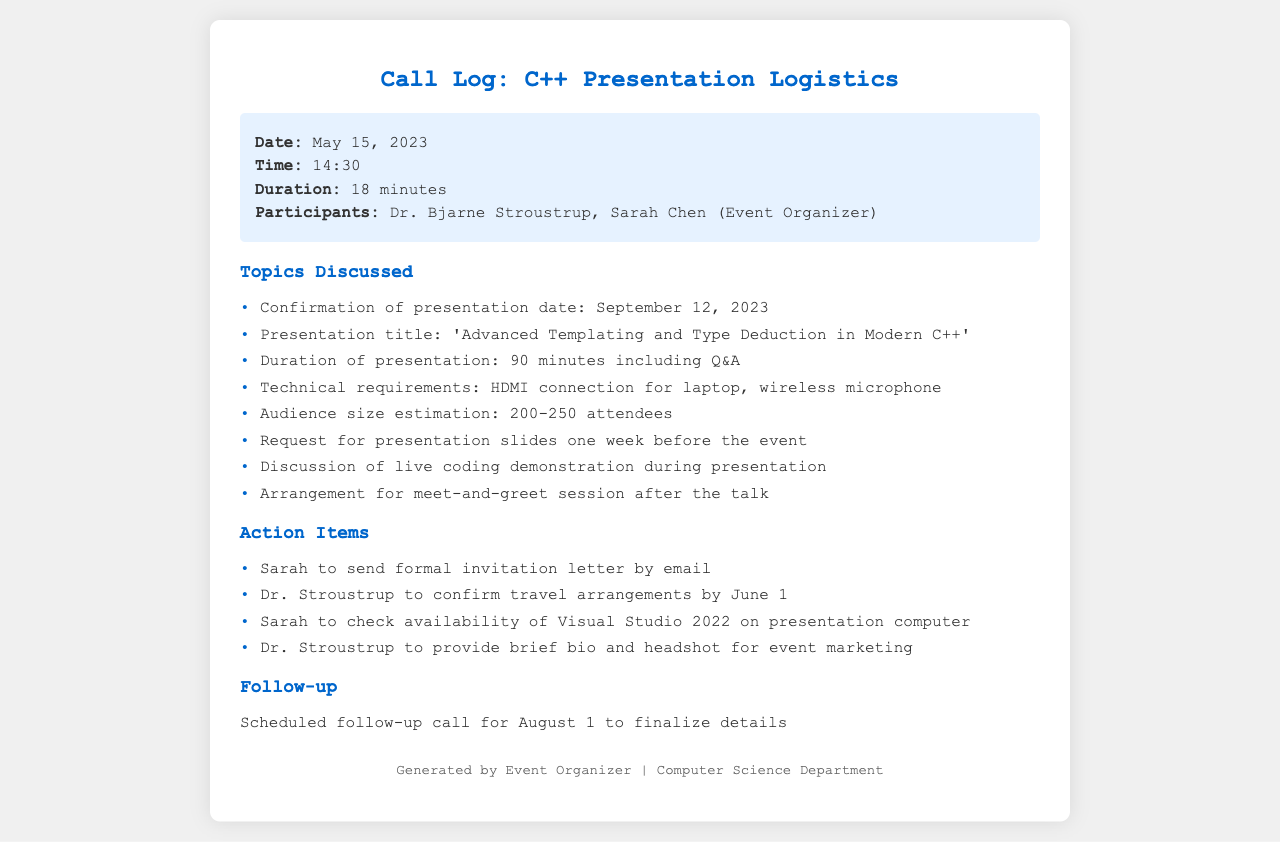What is the date of the call? The date of the call is mentioned in the call info section of the document.
Answer: May 15, 2023 Who is the professor invited to speak? The document lists the participants in the call, including the professor.
Answer: Dr. Bjarne Stroustrup What is the presentation title? The title of the presentation is explicitly stated in the topics discussed section.
Answer: Advanced Templating and Type Deduction in Modern C++ How long is the presentation scheduled to be? The document specifies the duration of the presentation in the topics discussed section.
Answer: 90 minutes What technical requirement is mentioned for the presentation? One of the technical requirements is listed in the topics discussed section.
Answer: HDMI connection for laptop When is the follow-up call scheduled? The follow-up date is provided in the follow-up section of the document.
Answer: August 1 How many attendees are estimated for the event? The document provides an estimation of the audience size in the topics discussed section.
Answer: 200-250 attendees What action item involves an email? The action items include specific tasks, one of which involves emailing.
Answer: Sarah to send formal invitation letter by email What is the deadline for confirming travel arrangements? The deadline for travel arrangements is mentioned in the action items.
Answer: June 1 